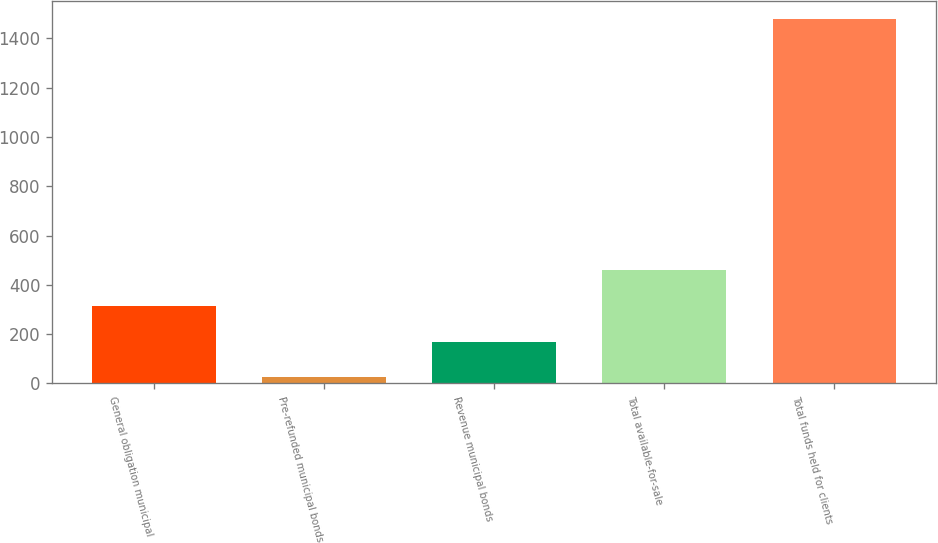<chart> <loc_0><loc_0><loc_500><loc_500><bar_chart><fcel>General obligation municipal<fcel>Pre-refunded municipal bonds<fcel>Revenue municipal bonds<fcel>Total available-for-sale<fcel>Total funds held for clients<nl><fcel>315.2<fcel>24<fcel>169.6<fcel>460.8<fcel>1480<nl></chart> 